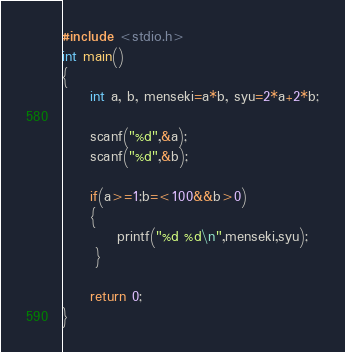<code> <loc_0><loc_0><loc_500><loc_500><_C_>#include <stdio.h>
int main()
{
     int a, b, menseki=a*b, syu=2*a+2*b;

     scanf("%d",&a);
     scanf("%d",&b);

     if(a>=1;b=<100&&b>0)
     {
          printf("%d %d\n",menseki,syu);
      }

     return 0;
}</code> 